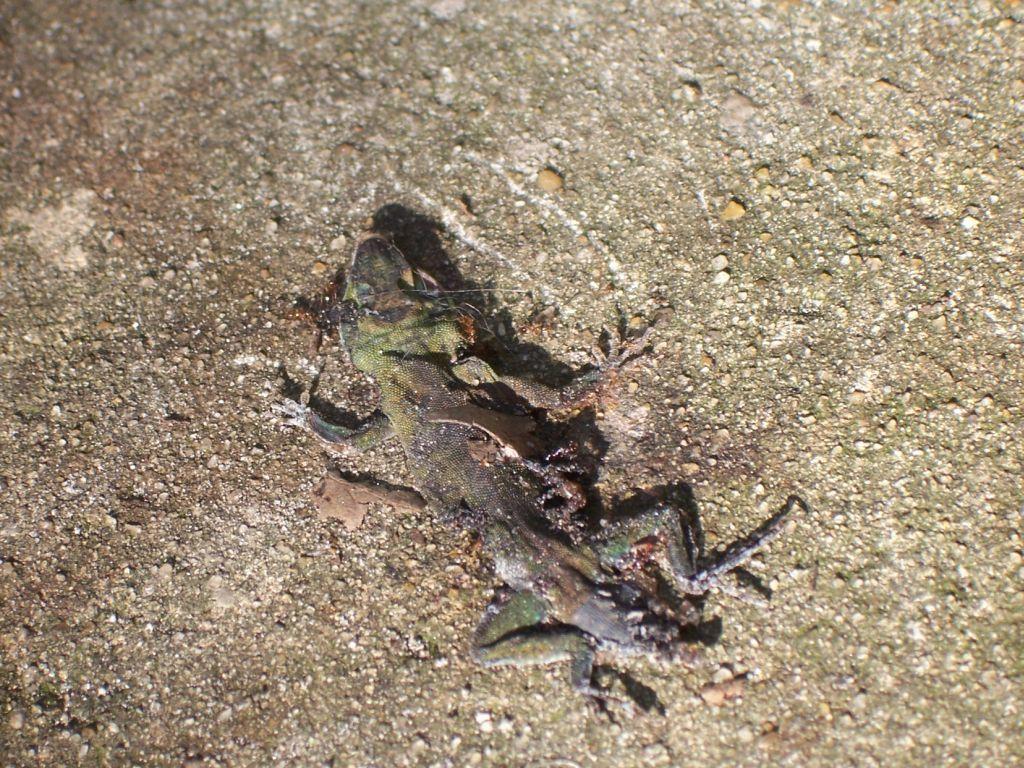Can you describe this image briefly? In this image there is a lizard on the surface. 